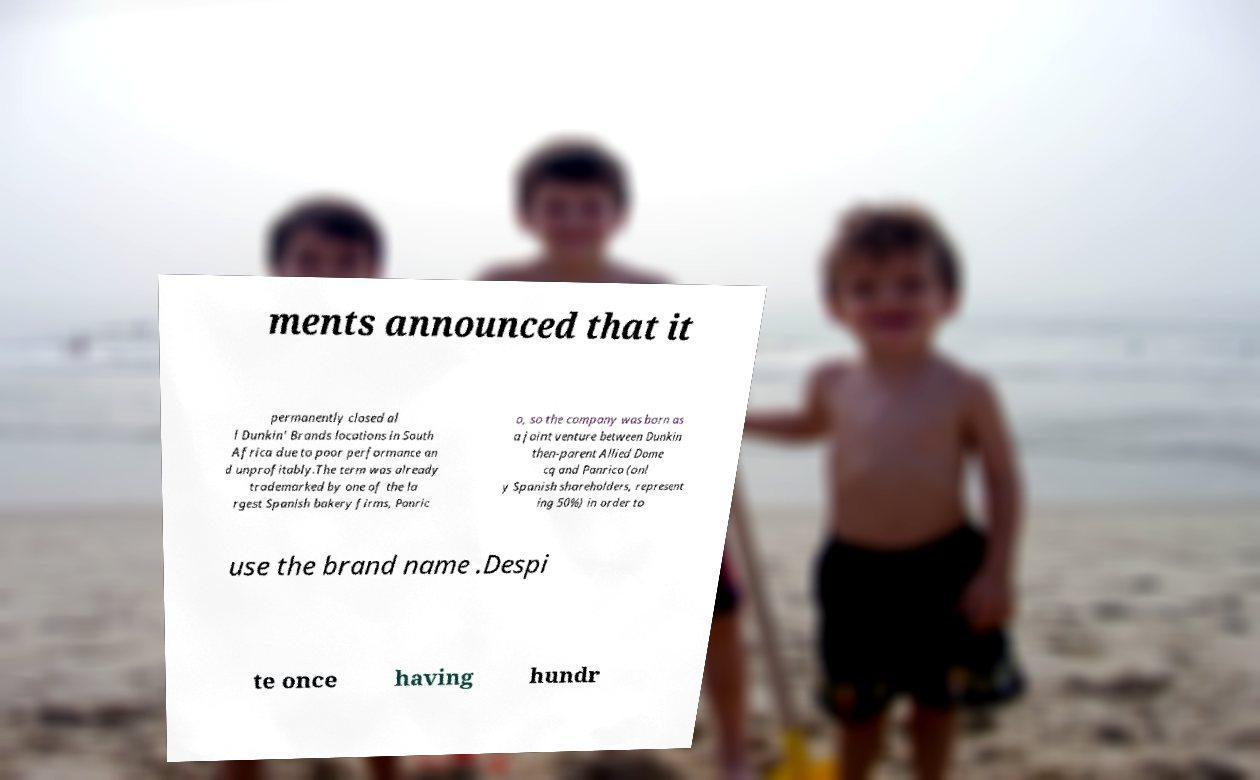Please identify and transcribe the text found in this image. ments announced that it permanently closed al l Dunkin' Brands locations in South Africa due to poor performance an d unprofitably.The term was already trademarked by one of the la rgest Spanish bakery firms, Panric o, so the company was born as a joint venture between Dunkin then-parent Allied Dome cq and Panrico (onl y Spanish shareholders, represent ing 50%) in order to use the brand name .Despi te once having hundr 